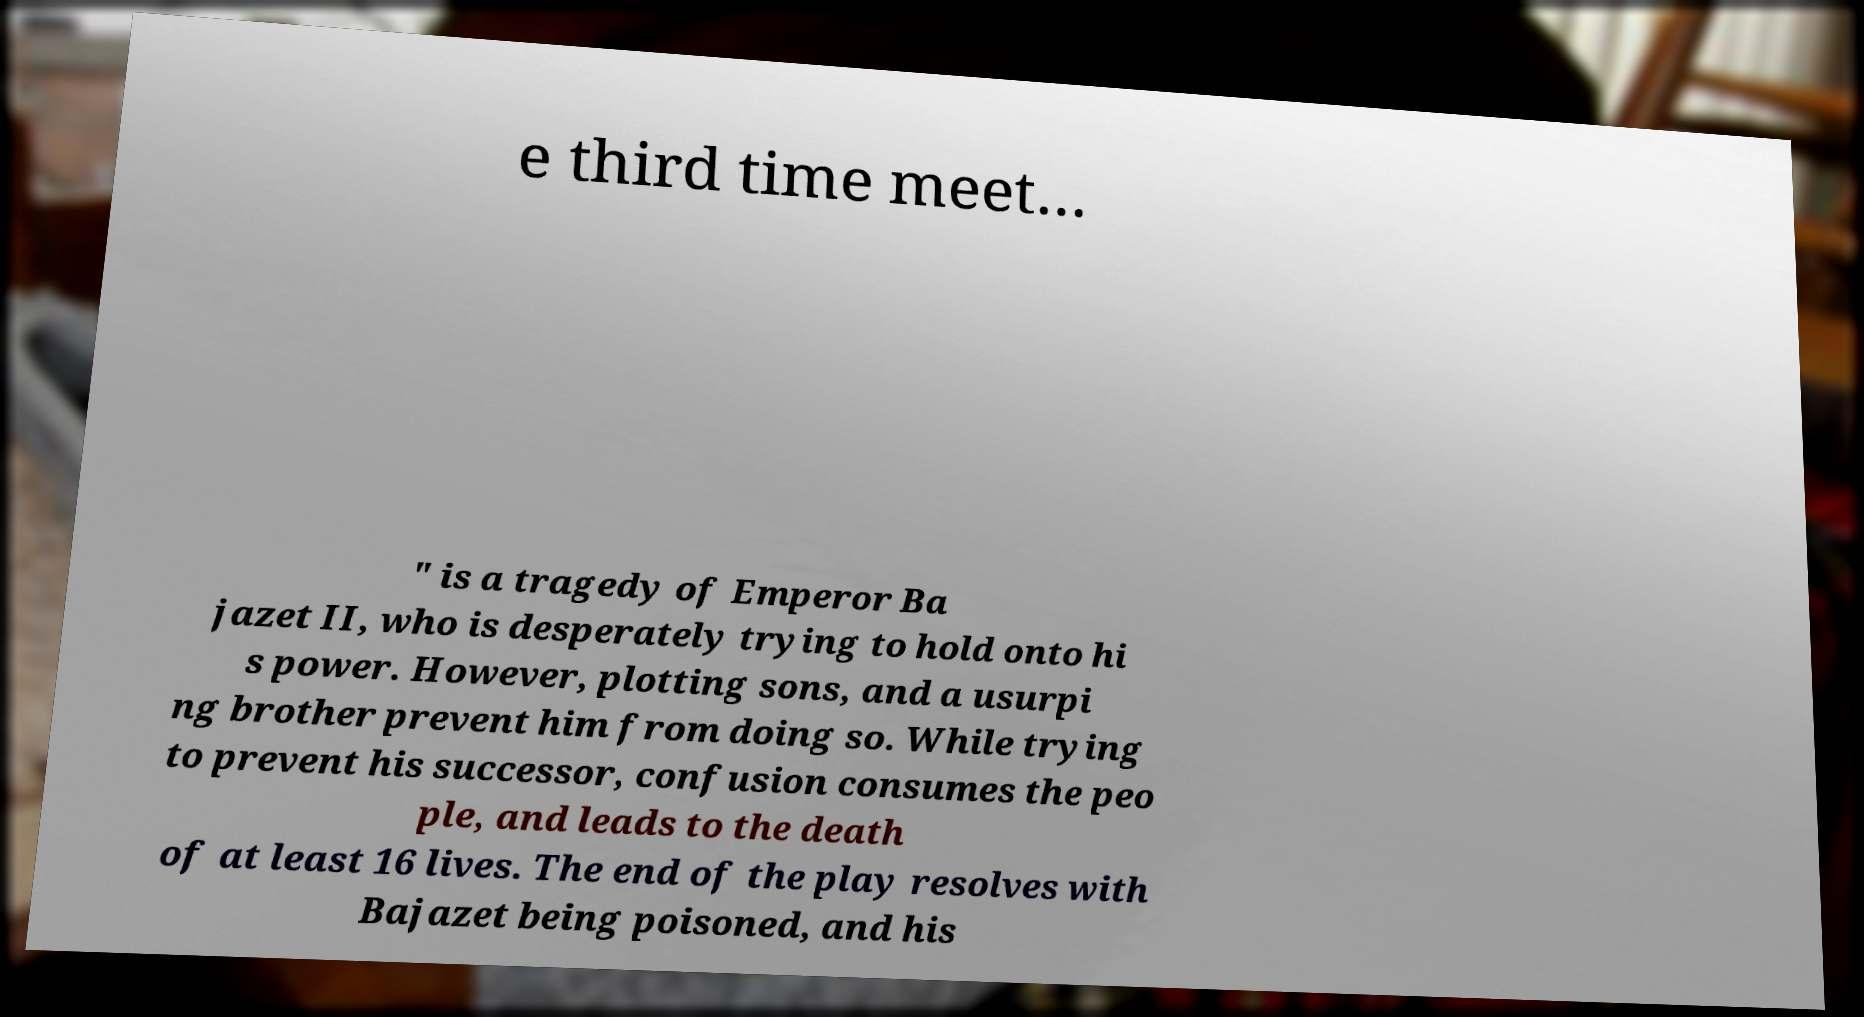Please identify and transcribe the text found in this image. e third time meet… " is a tragedy of Emperor Ba jazet II, who is desperately trying to hold onto hi s power. However, plotting sons, and a usurpi ng brother prevent him from doing so. While trying to prevent his successor, confusion consumes the peo ple, and leads to the death of at least 16 lives. The end of the play resolves with Bajazet being poisoned, and his 